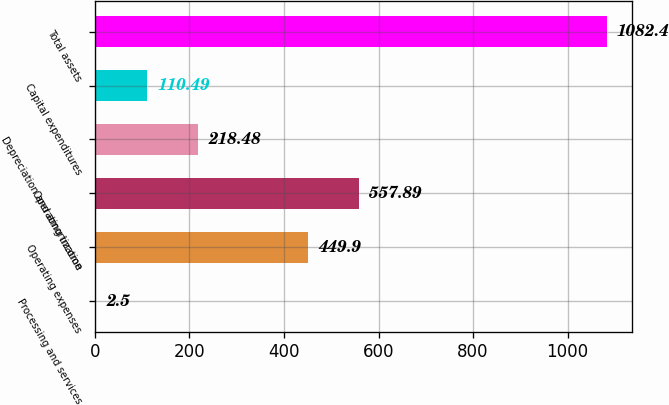Convert chart. <chart><loc_0><loc_0><loc_500><loc_500><bar_chart><fcel>Processing and services<fcel>Operating expenses<fcel>Operating income<fcel>Depreciation and amortization<fcel>Capital expenditures<fcel>Total assets<nl><fcel>2.5<fcel>449.9<fcel>557.89<fcel>218.48<fcel>110.49<fcel>1082.4<nl></chart> 